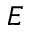<formula> <loc_0><loc_0><loc_500><loc_500>E</formula> 